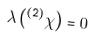<formula> <loc_0><loc_0><loc_500><loc_500>\lambda \left ( ^ { \tt ( 2 ) } \chi \right ) = 0 \,</formula> 